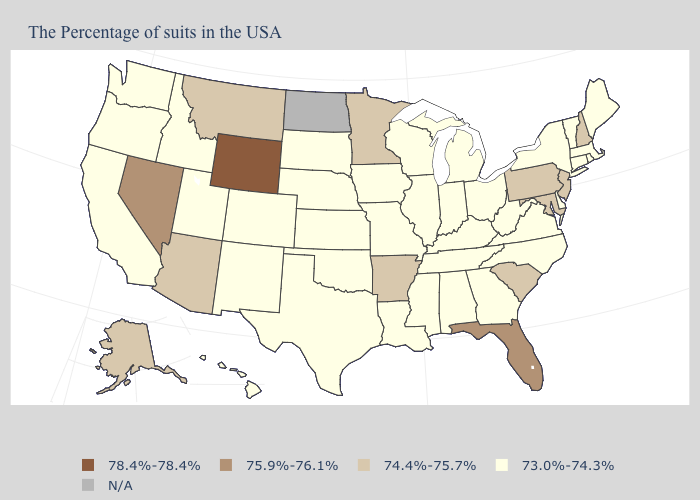Does Wyoming have the highest value in the USA?
Quick response, please. Yes. What is the value of South Carolina?
Write a very short answer. 74.4%-75.7%. Which states hav the highest value in the Northeast?
Concise answer only. New Hampshire, New Jersey, Pennsylvania. What is the value of Idaho?
Give a very brief answer. 73.0%-74.3%. Name the states that have a value in the range 73.0%-74.3%?
Write a very short answer. Maine, Massachusetts, Rhode Island, Vermont, Connecticut, New York, Delaware, Virginia, North Carolina, West Virginia, Ohio, Georgia, Michigan, Kentucky, Indiana, Alabama, Tennessee, Wisconsin, Illinois, Mississippi, Louisiana, Missouri, Iowa, Kansas, Nebraska, Oklahoma, Texas, South Dakota, Colorado, New Mexico, Utah, Idaho, California, Washington, Oregon, Hawaii. Name the states that have a value in the range 74.4%-75.7%?
Answer briefly. New Hampshire, New Jersey, Maryland, Pennsylvania, South Carolina, Arkansas, Minnesota, Montana, Arizona, Alaska. What is the lowest value in the South?
Keep it brief. 73.0%-74.3%. What is the value of North Dakota?
Concise answer only. N/A. Which states have the highest value in the USA?
Concise answer only. Wyoming. Name the states that have a value in the range 73.0%-74.3%?
Be succinct. Maine, Massachusetts, Rhode Island, Vermont, Connecticut, New York, Delaware, Virginia, North Carolina, West Virginia, Ohio, Georgia, Michigan, Kentucky, Indiana, Alabama, Tennessee, Wisconsin, Illinois, Mississippi, Louisiana, Missouri, Iowa, Kansas, Nebraska, Oklahoma, Texas, South Dakota, Colorado, New Mexico, Utah, Idaho, California, Washington, Oregon, Hawaii. Among the states that border Connecticut , which have the highest value?
Quick response, please. Massachusetts, Rhode Island, New York. Name the states that have a value in the range 75.9%-76.1%?
Give a very brief answer. Florida, Nevada. Among the states that border Texas , does New Mexico have the lowest value?
Be succinct. Yes. Does the map have missing data?
Write a very short answer. Yes. 